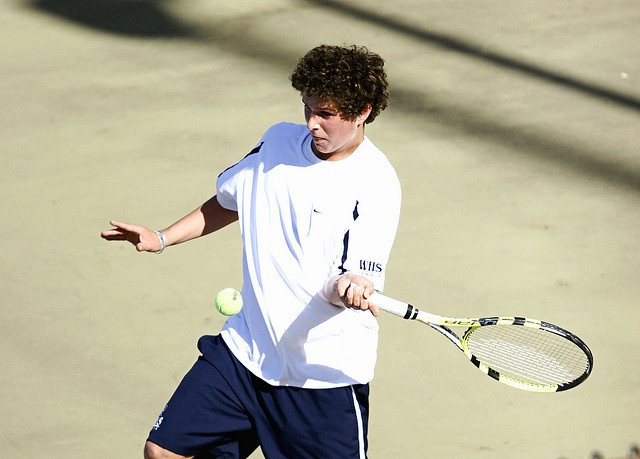Describe the objects in this image and their specific colors. I can see people in tan, white, black, navy, and darkgray tones, tennis racket in tan, beige, ivory, black, and darkgray tones, and sports ball in tan, lightyellow, khaki, lightgreen, and darkgray tones in this image. 